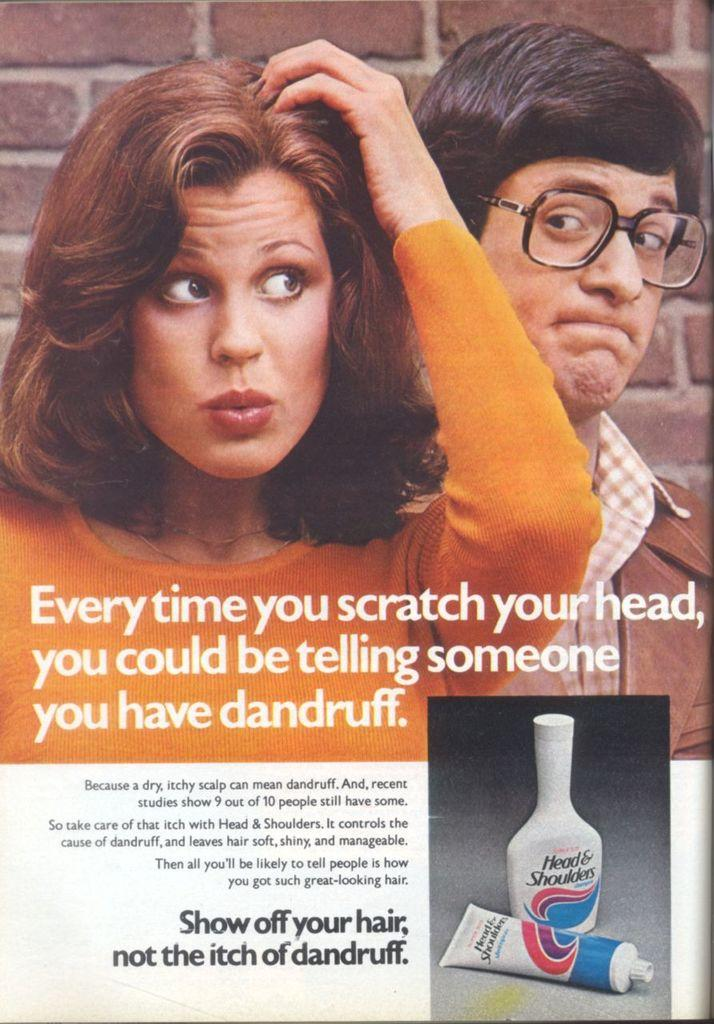Provide a one-sentence caption for the provided image. An advertisement for an anti dandruff shampoo from Head & Shoulders. 